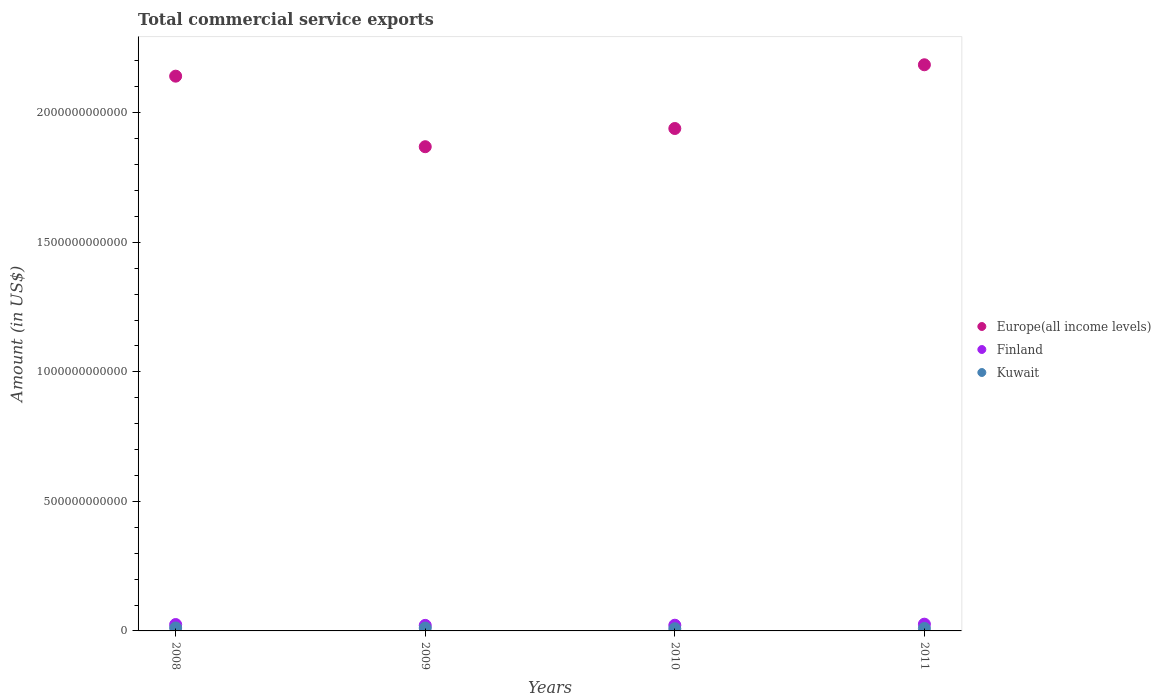How many different coloured dotlines are there?
Provide a succinct answer. 3. Is the number of dotlines equal to the number of legend labels?
Your answer should be very brief. Yes. What is the total commercial service exports in Europe(all income levels) in 2010?
Your response must be concise. 1.94e+12. Across all years, what is the maximum total commercial service exports in Kuwait?
Your answer should be very brief. 1.14e+1. Across all years, what is the minimum total commercial service exports in Europe(all income levels)?
Make the answer very short. 1.87e+12. In which year was the total commercial service exports in Europe(all income levels) maximum?
Provide a succinct answer. 2011. In which year was the total commercial service exports in Europe(all income levels) minimum?
Provide a short and direct response. 2009. What is the total total commercial service exports in Europe(all income levels) in the graph?
Provide a succinct answer. 8.14e+12. What is the difference between the total commercial service exports in Finland in 2008 and that in 2010?
Keep it short and to the point. 2.58e+09. What is the difference between the total commercial service exports in Europe(all income levels) in 2011 and the total commercial service exports in Kuwait in 2010?
Ensure brevity in your answer.  2.18e+12. What is the average total commercial service exports in Kuwait per year?
Offer a very short reply. 1.01e+1. In the year 2008, what is the difference between the total commercial service exports in Europe(all income levels) and total commercial service exports in Finland?
Offer a terse response. 2.12e+12. What is the ratio of the total commercial service exports in Finland in 2009 to that in 2010?
Your response must be concise. 0.97. Is the total commercial service exports in Kuwait in 2008 less than that in 2011?
Your response must be concise. No. Is the difference between the total commercial service exports in Europe(all income levels) in 2010 and 2011 greater than the difference between the total commercial service exports in Finland in 2010 and 2011?
Ensure brevity in your answer.  No. What is the difference between the highest and the second highest total commercial service exports in Kuwait?
Offer a very short reply. 3.67e+08. What is the difference between the highest and the lowest total commercial service exports in Kuwait?
Your response must be concise. 2.93e+09. In how many years, is the total commercial service exports in Finland greater than the average total commercial service exports in Finland taken over all years?
Keep it short and to the point. 2. Is it the case that in every year, the sum of the total commercial service exports in Finland and total commercial service exports in Kuwait  is greater than the total commercial service exports in Europe(all income levels)?
Your answer should be very brief. No. Is the total commercial service exports in Europe(all income levels) strictly greater than the total commercial service exports in Finland over the years?
Keep it short and to the point. Yes. Is the total commercial service exports in Finland strictly less than the total commercial service exports in Kuwait over the years?
Your answer should be very brief. No. What is the difference between two consecutive major ticks on the Y-axis?
Your response must be concise. 5.00e+11. How many legend labels are there?
Keep it short and to the point. 3. What is the title of the graph?
Your answer should be compact. Total commercial service exports. What is the label or title of the X-axis?
Ensure brevity in your answer.  Years. What is the label or title of the Y-axis?
Provide a short and direct response. Amount (in US$). What is the Amount (in US$) of Europe(all income levels) in 2008?
Keep it short and to the point. 2.14e+12. What is the Amount (in US$) in Finland in 2008?
Give a very brief answer. 2.46e+1. What is the Amount (in US$) of Kuwait in 2008?
Your response must be concise. 1.14e+1. What is the Amount (in US$) in Europe(all income levels) in 2009?
Offer a very short reply. 1.87e+12. What is the Amount (in US$) of Finland in 2009?
Ensure brevity in your answer.  2.14e+1. What is the Amount (in US$) in Kuwait in 2009?
Ensure brevity in your answer.  1.10e+1. What is the Amount (in US$) of Europe(all income levels) in 2010?
Offer a very short reply. 1.94e+12. What is the Amount (in US$) of Finland in 2010?
Make the answer very short. 2.20e+1. What is the Amount (in US$) in Kuwait in 2010?
Offer a terse response. 8.43e+09. What is the Amount (in US$) of Europe(all income levels) in 2011?
Your response must be concise. 2.19e+12. What is the Amount (in US$) of Finland in 2011?
Your response must be concise. 2.61e+1. What is the Amount (in US$) in Kuwait in 2011?
Your answer should be compact. 9.50e+09. Across all years, what is the maximum Amount (in US$) in Europe(all income levels)?
Keep it short and to the point. 2.19e+12. Across all years, what is the maximum Amount (in US$) in Finland?
Your response must be concise. 2.61e+1. Across all years, what is the maximum Amount (in US$) in Kuwait?
Ensure brevity in your answer.  1.14e+1. Across all years, what is the minimum Amount (in US$) in Europe(all income levels)?
Your response must be concise. 1.87e+12. Across all years, what is the minimum Amount (in US$) of Finland?
Ensure brevity in your answer.  2.14e+1. Across all years, what is the minimum Amount (in US$) in Kuwait?
Provide a succinct answer. 8.43e+09. What is the total Amount (in US$) in Europe(all income levels) in the graph?
Ensure brevity in your answer.  8.14e+12. What is the total Amount (in US$) of Finland in the graph?
Ensure brevity in your answer.  9.41e+1. What is the total Amount (in US$) in Kuwait in the graph?
Offer a very short reply. 4.03e+1. What is the difference between the Amount (in US$) of Europe(all income levels) in 2008 and that in 2009?
Make the answer very short. 2.72e+11. What is the difference between the Amount (in US$) of Finland in 2008 and that in 2009?
Provide a short and direct response. 3.20e+09. What is the difference between the Amount (in US$) of Kuwait in 2008 and that in 2009?
Provide a short and direct response. 3.67e+08. What is the difference between the Amount (in US$) in Europe(all income levels) in 2008 and that in 2010?
Offer a terse response. 2.02e+11. What is the difference between the Amount (in US$) in Finland in 2008 and that in 2010?
Give a very brief answer. 2.58e+09. What is the difference between the Amount (in US$) in Kuwait in 2008 and that in 2010?
Offer a very short reply. 2.93e+09. What is the difference between the Amount (in US$) in Europe(all income levels) in 2008 and that in 2011?
Offer a terse response. -4.40e+1. What is the difference between the Amount (in US$) of Finland in 2008 and that in 2011?
Make the answer very short. -1.44e+09. What is the difference between the Amount (in US$) of Kuwait in 2008 and that in 2011?
Provide a succinct answer. 1.86e+09. What is the difference between the Amount (in US$) in Europe(all income levels) in 2009 and that in 2010?
Offer a very short reply. -7.03e+1. What is the difference between the Amount (in US$) in Finland in 2009 and that in 2010?
Provide a succinct answer. -6.22e+08. What is the difference between the Amount (in US$) of Kuwait in 2009 and that in 2010?
Keep it short and to the point. 2.57e+09. What is the difference between the Amount (in US$) in Europe(all income levels) in 2009 and that in 2011?
Give a very brief answer. -3.16e+11. What is the difference between the Amount (in US$) of Finland in 2009 and that in 2011?
Your response must be concise. -4.64e+09. What is the difference between the Amount (in US$) in Kuwait in 2009 and that in 2011?
Offer a very short reply. 1.49e+09. What is the difference between the Amount (in US$) in Europe(all income levels) in 2010 and that in 2011?
Provide a succinct answer. -2.46e+11. What is the difference between the Amount (in US$) of Finland in 2010 and that in 2011?
Your answer should be compact. -4.02e+09. What is the difference between the Amount (in US$) of Kuwait in 2010 and that in 2011?
Provide a succinct answer. -1.07e+09. What is the difference between the Amount (in US$) of Europe(all income levels) in 2008 and the Amount (in US$) of Finland in 2009?
Provide a succinct answer. 2.12e+12. What is the difference between the Amount (in US$) in Europe(all income levels) in 2008 and the Amount (in US$) in Kuwait in 2009?
Provide a succinct answer. 2.13e+12. What is the difference between the Amount (in US$) in Finland in 2008 and the Amount (in US$) in Kuwait in 2009?
Offer a terse response. 1.36e+1. What is the difference between the Amount (in US$) of Europe(all income levels) in 2008 and the Amount (in US$) of Finland in 2010?
Provide a short and direct response. 2.12e+12. What is the difference between the Amount (in US$) in Europe(all income levels) in 2008 and the Amount (in US$) in Kuwait in 2010?
Provide a succinct answer. 2.13e+12. What is the difference between the Amount (in US$) in Finland in 2008 and the Amount (in US$) in Kuwait in 2010?
Make the answer very short. 1.62e+1. What is the difference between the Amount (in US$) in Europe(all income levels) in 2008 and the Amount (in US$) in Finland in 2011?
Your answer should be very brief. 2.12e+12. What is the difference between the Amount (in US$) of Europe(all income levels) in 2008 and the Amount (in US$) of Kuwait in 2011?
Give a very brief answer. 2.13e+12. What is the difference between the Amount (in US$) of Finland in 2008 and the Amount (in US$) of Kuwait in 2011?
Make the answer very short. 1.51e+1. What is the difference between the Amount (in US$) of Europe(all income levels) in 2009 and the Amount (in US$) of Finland in 2010?
Your response must be concise. 1.85e+12. What is the difference between the Amount (in US$) of Europe(all income levels) in 2009 and the Amount (in US$) of Kuwait in 2010?
Keep it short and to the point. 1.86e+12. What is the difference between the Amount (in US$) in Finland in 2009 and the Amount (in US$) in Kuwait in 2010?
Provide a short and direct response. 1.30e+1. What is the difference between the Amount (in US$) in Europe(all income levels) in 2009 and the Amount (in US$) in Finland in 2011?
Your answer should be compact. 1.84e+12. What is the difference between the Amount (in US$) in Europe(all income levels) in 2009 and the Amount (in US$) in Kuwait in 2011?
Your response must be concise. 1.86e+12. What is the difference between the Amount (in US$) of Finland in 2009 and the Amount (in US$) of Kuwait in 2011?
Offer a terse response. 1.19e+1. What is the difference between the Amount (in US$) in Europe(all income levels) in 2010 and the Amount (in US$) in Finland in 2011?
Ensure brevity in your answer.  1.91e+12. What is the difference between the Amount (in US$) in Europe(all income levels) in 2010 and the Amount (in US$) in Kuwait in 2011?
Offer a terse response. 1.93e+12. What is the difference between the Amount (in US$) of Finland in 2010 and the Amount (in US$) of Kuwait in 2011?
Ensure brevity in your answer.  1.25e+1. What is the average Amount (in US$) of Europe(all income levels) per year?
Keep it short and to the point. 2.03e+12. What is the average Amount (in US$) in Finland per year?
Your response must be concise. 2.35e+1. What is the average Amount (in US$) of Kuwait per year?
Your answer should be compact. 1.01e+1. In the year 2008, what is the difference between the Amount (in US$) of Europe(all income levels) and Amount (in US$) of Finland?
Give a very brief answer. 2.12e+12. In the year 2008, what is the difference between the Amount (in US$) in Europe(all income levels) and Amount (in US$) in Kuwait?
Your answer should be compact. 2.13e+12. In the year 2008, what is the difference between the Amount (in US$) of Finland and Amount (in US$) of Kuwait?
Provide a short and direct response. 1.33e+1. In the year 2009, what is the difference between the Amount (in US$) in Europe(all income levels) and Amount (in US$) in Finland?
Offer a terse response. 1.85e+12. In the year 2009, what is the difference between the Amount (in US$) in Europe(all income levels) and Amount (in US$) in Kuwait?
Give a very brief answer. 1.86e+12. In the year 2009, what is the difference between the Amount (in US$) in Finland and Amount (in US$) in Kuwait?
Give a very brief answer. 1.04e+1. In the year 2010, what is the difference between the Amount (in US$) in Europe(all income levels) and Amount (in US$) in Finland?
Provide a succinct answer. 1.92e+12. In the year 2010, what is the difference between the Amount (in US$) of Europe(all income levels) and Amount (in US$) of Kuwait?
Make the answer very short. 1.93e+12. In the year 2010, what is the difference between the Amount (in US$) of Finland and Amount (in US$) of Kuwait?
Your response must be concise. 1.36e+1. In the year 2011, what is the difference between the Amount (in US$) of Europe(all income levels) and Amount (in US$) of Finland?
Your answer should be very brief. 2.16e+12. In the year 2011, what is the difference between the Amount (in US$) in Europe(all income levels) and Amount (in US$) in Kuwait?
Your response must be concise. 2.18e+12. In the year 2011, what is the difference between the Amount (in US$) of Finland and Amount (in US$) of Kuwait?
Your answer should be compact. 1.66e+1. What is the ratio of the Amount (in US$) of Europe(all income levels) in 2008 to that in 2009?
Ensure brevity in your answer.  1.15. What is the ratio of the Amount (in US$) of Finland in 2008 to that in 2009?
Give a very brief answer. 1.15. What is the ratio of the Amount (in US$) of Kuwait in 2008 to that in 2009?
Give a very brief answer. 1.03. What is the ratio of the Amount (in US$) in Europe(all income levels) in 2008 to that in 2010?
Provide a succinct answer. 1.1. What is the ratio of the Amount (in US$) in Finland in 2008 to that in 2010?
Ensure brevity in your answer.  1.12. What is the ratio of the Amount (in US$) of Kuwait in 2008 to that in 2010?
Your response must be concise. 1.35. What is the ratio of the Amount (in US$) in Europe(all income levels) in 2008 to that in 2011?
Offer a terse response. 0.98. What is the ratio of the Amount (in US$) in Finland in 2008 to that in 2011?
Keep it short and to the point. 0.94. What is the ratio of the Amount (in US$) in Kuwait in 2008 to that in 2011?
Provide a short and direct response. 1.2. What is the ratio of the Amount (in US$) in Europe(all income levels) in 2009 to that in 2010?
Your response must be concise. 0.96. What is the ratio of the Amount (in US$) of Finland in 2009 to that in 2010?
Provide a succinct answer. 0.97. What is the ratio of the Amount (in US$) of Kuwait in 2009 to that in 2010?
Your answer should be compact. 1.3. What is the ratio of the Amount (in US$) of Europe(all income levels) in 2009 to that in 2011?
Offer a very short reply. 0.86. What is the ratio of the Amount (in US$) in Finland in 2009 to that in 2011?
Make the answer very short. 0.82. What is the ratio of the Amount (in US$) of Kuwait in 2009 to that in 2011?
Offer a terse response. 1.16. What is the ratio of the Amount (in US$) in Europe(all income levels) in 2010 to that in 2011?
Give a very brief answer. 0.89. What is the ratio of the Amount (in US$) of Finland in 2010 to that in 2011?
Offer a very short reply. 0.85. What is the ratio of the Amount (in US$) in Kuwait in 2010 to that in 2011?
Provide a succinct answer. 0.89. What is the difference between the highest and the second highest Amount (in US$) in Europe(all income levels)?
Keep it short and to the point. 4.40e+1. What is the difference between the highest and the second highest Amount (in US$) in Finland?
Make the answer very short. 1.44e+09. What is the difference between the highest and the second highest Amount (in US$) in Kuwait?
Provide a short and direct response. 3.67e+08. What is the difference between the highest and the lowest Amount (in US$) of Europe(all income levels)?
Provide a succinct answer. 3.16e+11. What is the difference between the highest and the lowest Amount (in US$) of Finland?
Your answer should be compact. 4.64e+09. What is the difference between the highest and the lowest Amount (in US$) of Kuwait?
Your answer should be very brief. 2.93e+09. 